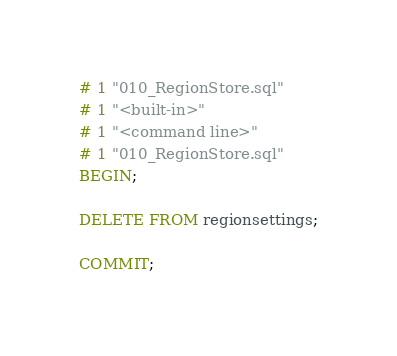Convert code to text. <code><loc_0><loc_0><loc_500><loc_500><_SQL_># 1 "010_RegionStore.sql"
# 1 "<built-in>"
# 1 "<command line>"
# 1 "010_RegionStore.sql"
BEGIN;

DELETE FROM regionsettings;

COMMIT;
</code> 